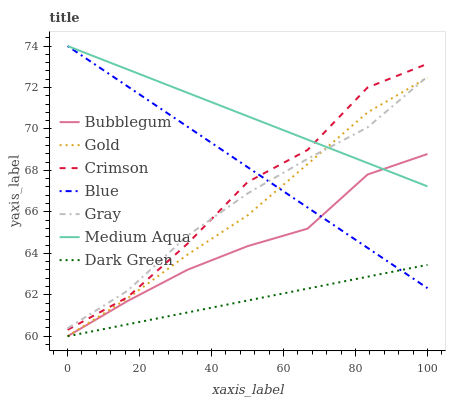Does Dark Green have the minimum area under the curve?
Answer yes or no. Yes. Does Medium Aqua have the maximum area under the curve?
Answer yes or no. Yes. Does Gray have the minimum area under the curve?
Answer yes or no. No. Does Gray have the maximum area under the curve?
Answer yes or no. No. Is Dark Green the smoothest?
Answer yes or no. Yes. Is Crimson the roughest?
Answer yes or no. Yes. Is Gray the smoothest?
Answer yes or no. No. Is Gray the roughest?
Answer yes or no. No. Does Gold have the lowest value?
Answer yes or no. Yes. Does Gray have the lowest value?
Answer yes or no. No. Does Medium Aqua have the highest value?
Answer yes or no. Yes. Does Gray have the highest value?
Answer yes or no. No. Is Dark Green less than Gray?
Answer yes or no. Yes. Is Crimson greater than Dark Green?
Answer yes or no. Yes. Does Gray intersect Medium Aqua?
Answer yes or no. Yes. Is Gray less than Medium Aqua?
Answer yes or no. No. Is Gray greater than Medium Aqua?
Answer yes or no. No. Does Dark Green intersect Gray?
Answer yes or no. No. 